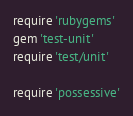Convert code to text. <code><loc_0><loc_0><loc_500><loc_500><_Ruby_>require 'rubygems'
gem 'test-unit'
require 'test/unit'

require 'possessive'
</code> 